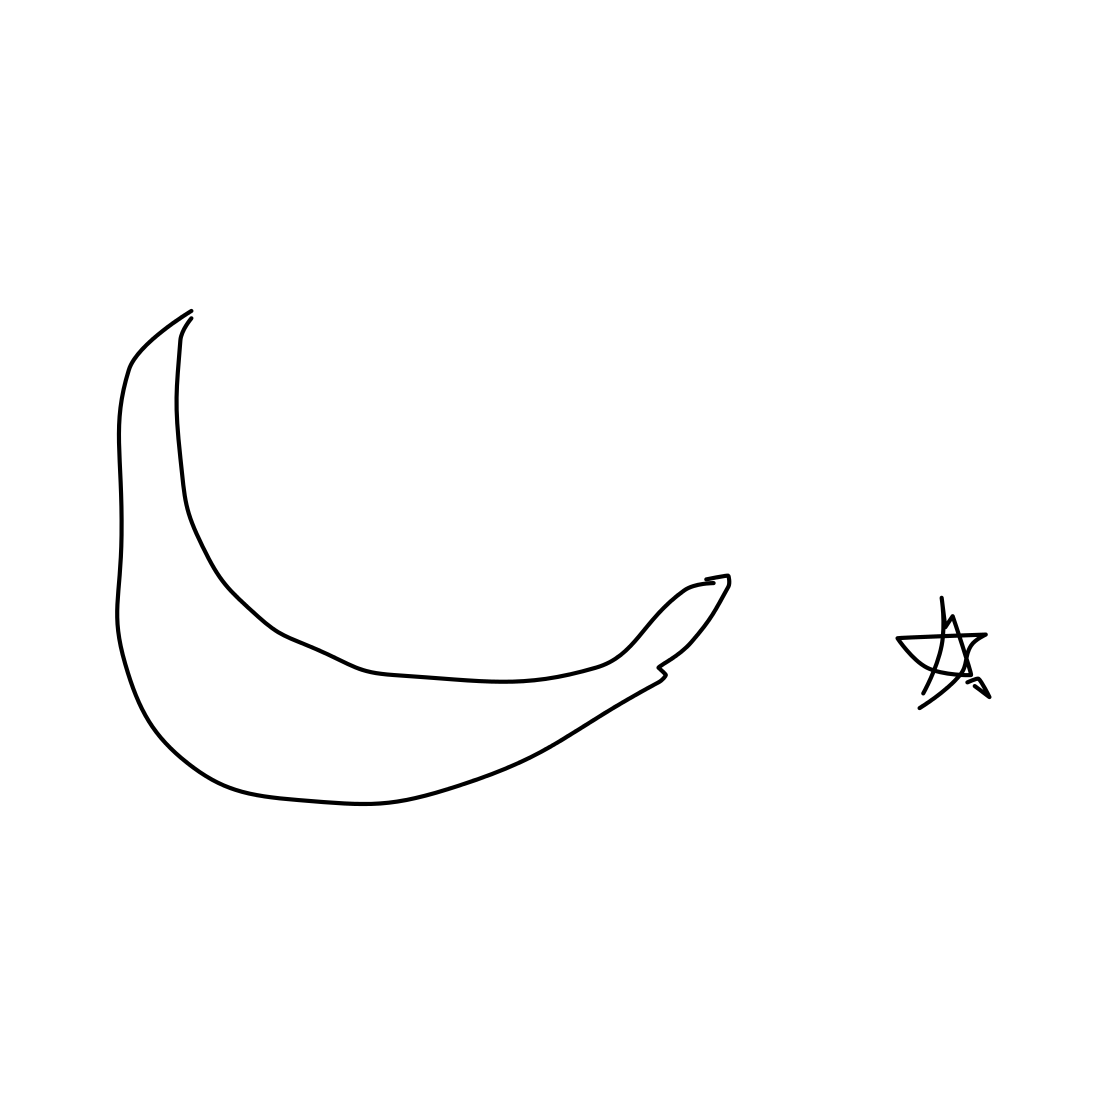Each image is a human drawn sketch of an object. Identify the main object in the image. The primary object depicted in this sketch is a banana, which is highlighted by its distinctive elongated and curved form. The illustration simplifies but effectively captures the typical features of a banana, including the segmented lines that often represent the sections of the peel. Adjacent to it, there is a small drawing of what appears to be a star, adding an element of whimsy or symbolic meaning to the composition. This could suggest a thematic or artistic juxtaposition in the creator's intention—perhaps hinting at something 'stellar' or 'outstanding' about the mundane fruit. 